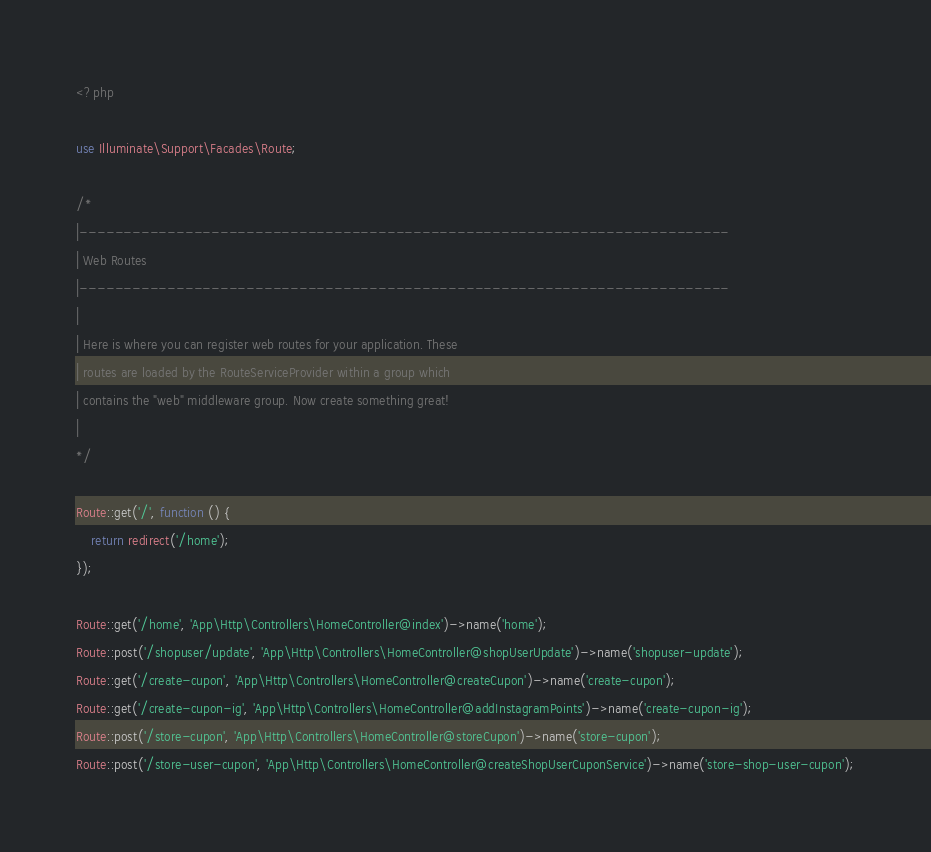<code> <loc_0><loc_0><loc_500><loc_500><_PHP_><?php

use Illuminate\Support\Facades\Route;

/*
|--------------------------------------------------------------------------
| Web Routes
|--------------------------------------------------------------------------
|
| Here is where you can register web routes for your application. These
| routes are loaded by the RouteServiceProvider within a group which
| contains the "web" middleware group. Now create something great!
|
*/

Route::get('/', function () {
    return redirect('/home');
});

Route::get('/home', 'App\Http\Controllers\HomeController@index')->name('home');
Route::post('/shopuser/update', 'App\Http\Controllers\HomeController@shopUserUpdate')->name('shopuser-update');
Route::get('/create-cupon', 'App\Http\Controllers\HomeController@createCupon')->name('create-cupon');
Route::get('/create-cupon-ig', 'App\Http\Controllers\HomeController@addInstagramPoints')->name('create-cupon-ig');
Route::post('/store-cupon', 'App\Http\Controllers\HomeController@storeCupon')->name('store-cupon');
Route::post('/store-user-cupon', 'App\Http\Controllers\HomeController@createShopUserCuponService')->name('store-shop-user-cupon');

</code> 